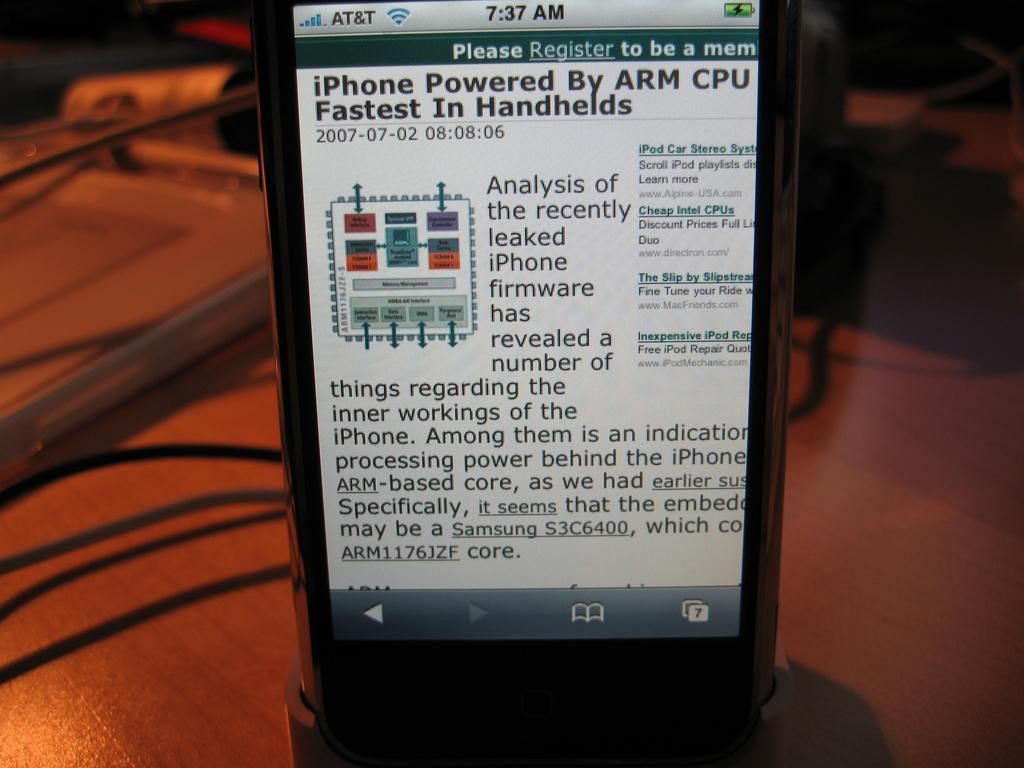What electronic device is visible in the image? There is a mobile phone in the image. What can be seen on the mobile phone? The mobile phone has a display. What else is present in the image besides the mobile phone? There are cables in the image. What type of surface are the objects placed on? The objects are placed on a wooden table. How would you describe the background of the image? The background of the image appears blurry. What type of van is parked in the background of the image? There is no van present in the image; the background appears blurry. What is the sum of the numbers 5 and 7 in the image? There are no numbers present in the image, so it is not possible to perform an addition operation. 